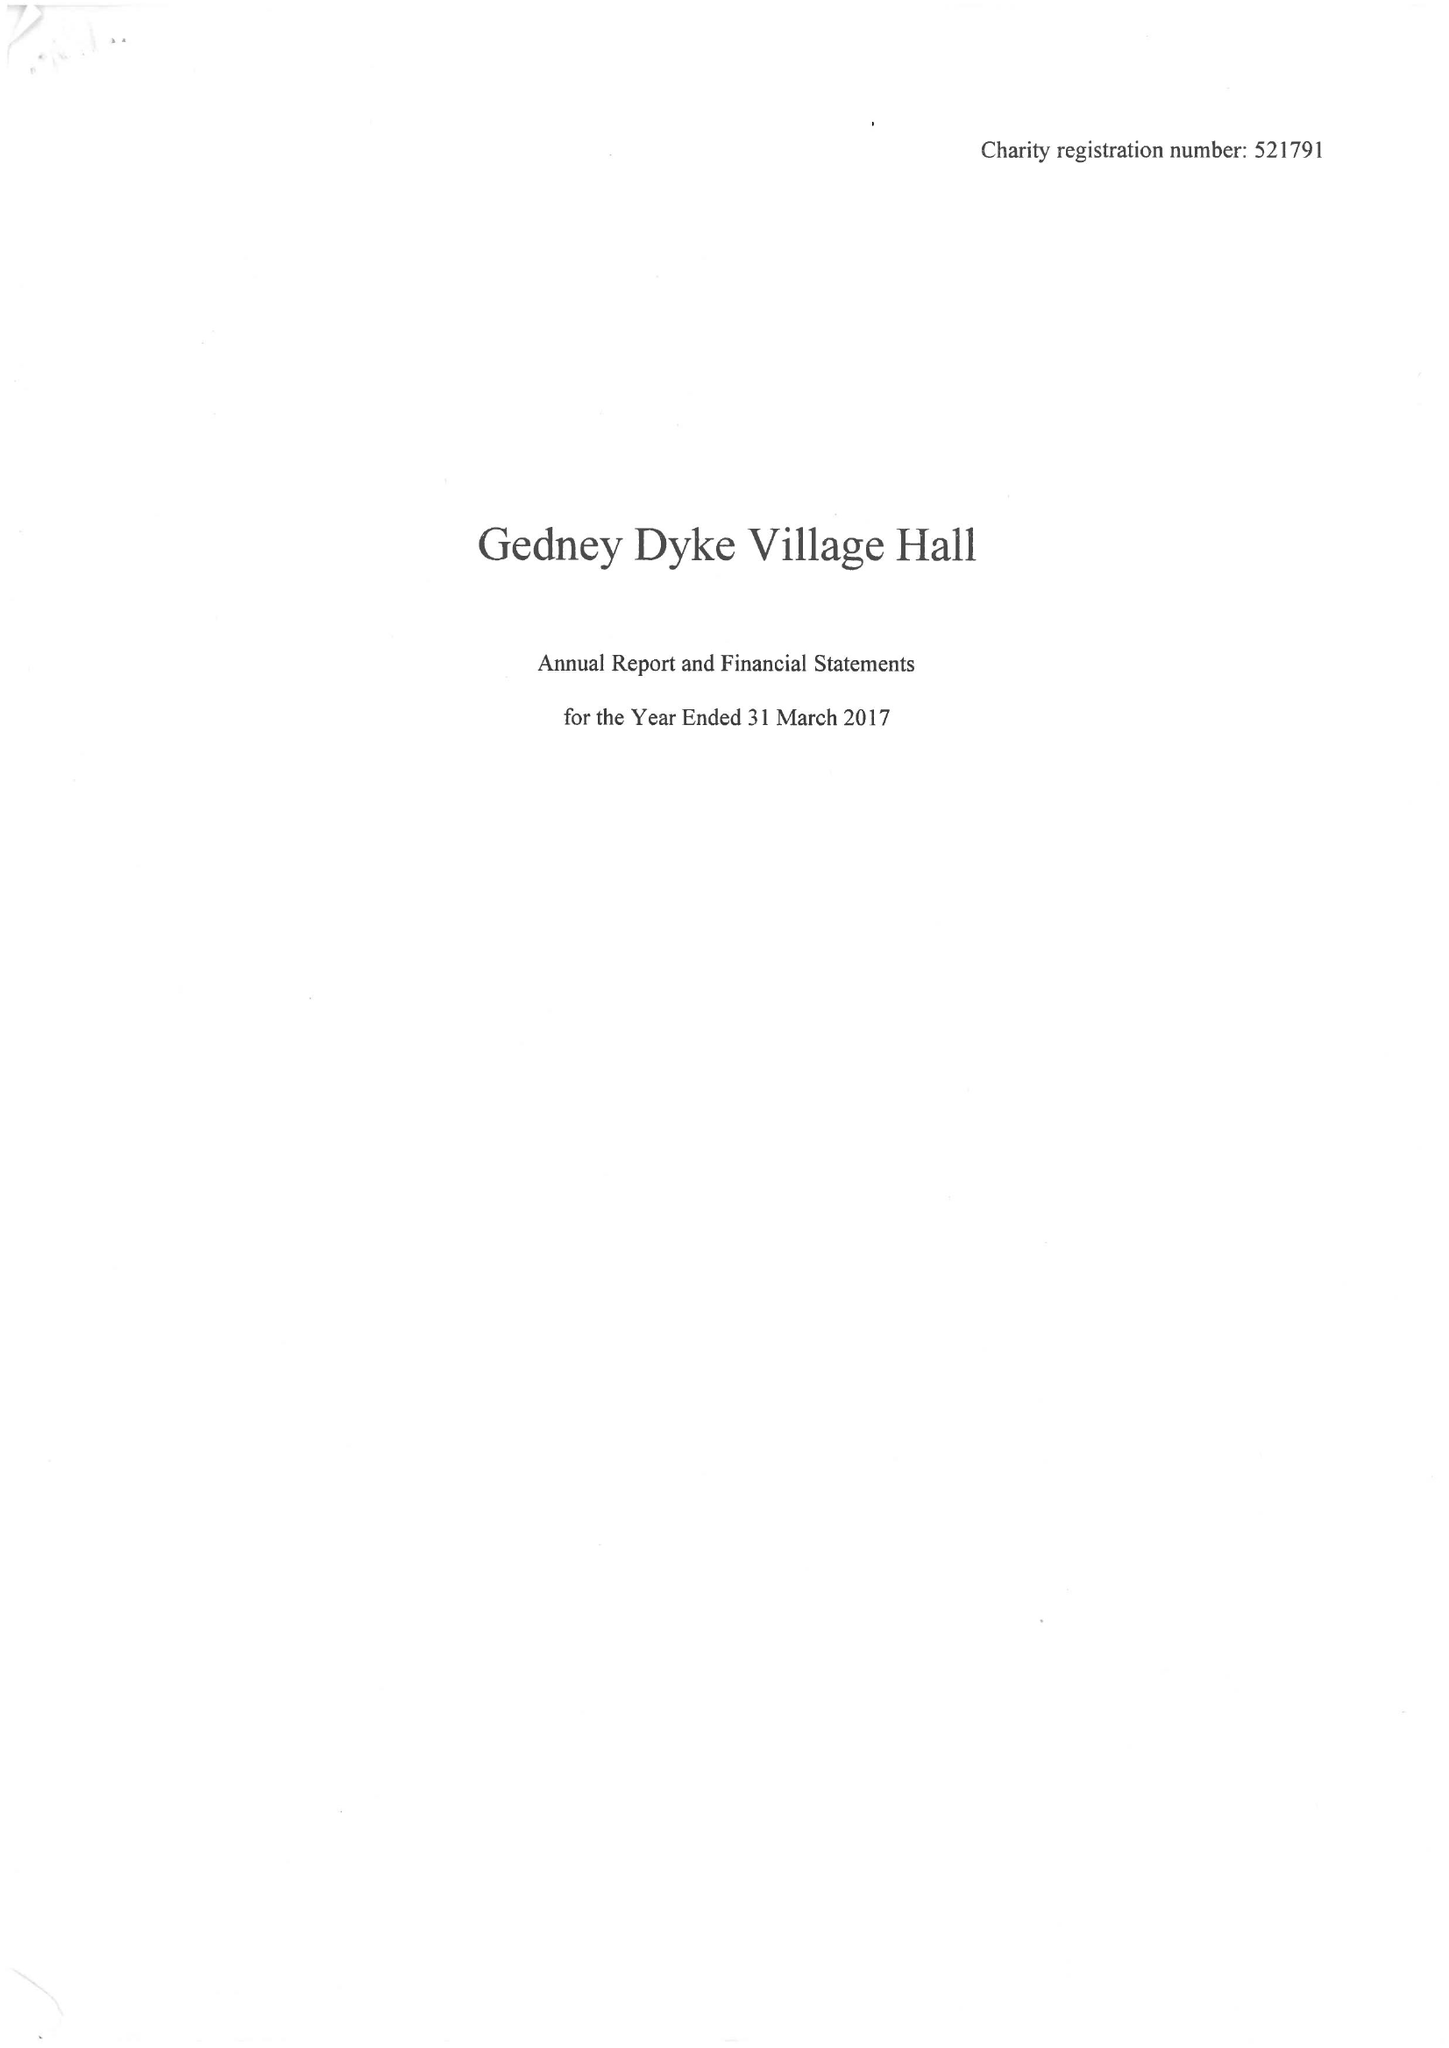What is the value for the spending_annually_in_british_pounds?
Answer the question using a single word or phrase. 18622.00 